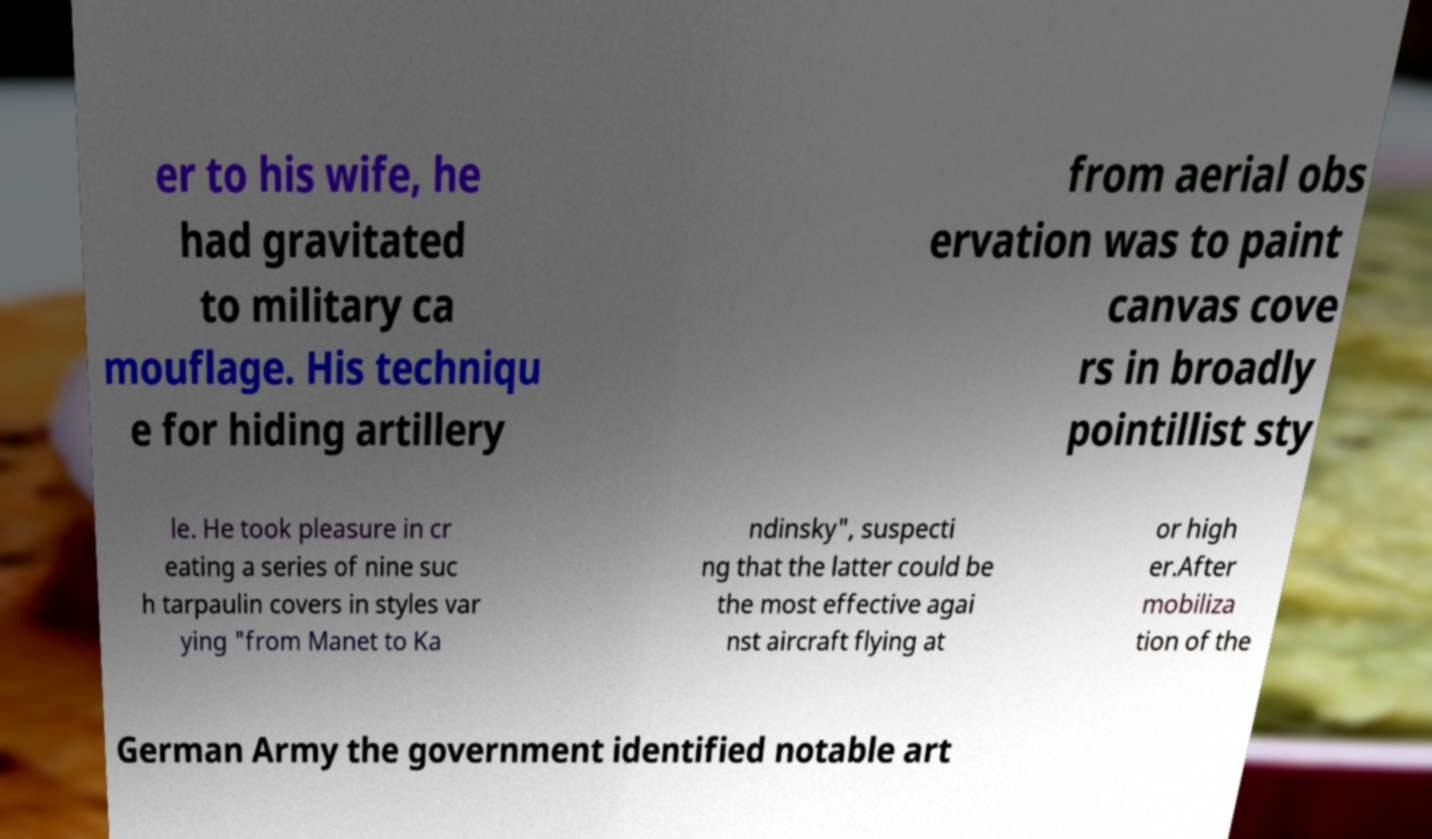Can you accurately transcribe the text from the provided image for me? er to his wife, he had gravitated to military ca mouflage. His techniqu e for hiding artillery from aerial obs ervation was to paint canvas cove rs in broadly pointillist sty le. He took pleasure in cr eating a series of nine suc h tarpaulin covers in styles var ying "from Manet to Ka ndinsky", suspecti ng that the latter could be the most effective agai nst aircraft flying at or high er.After mobiliza tion of the German Army the government identified notable art 